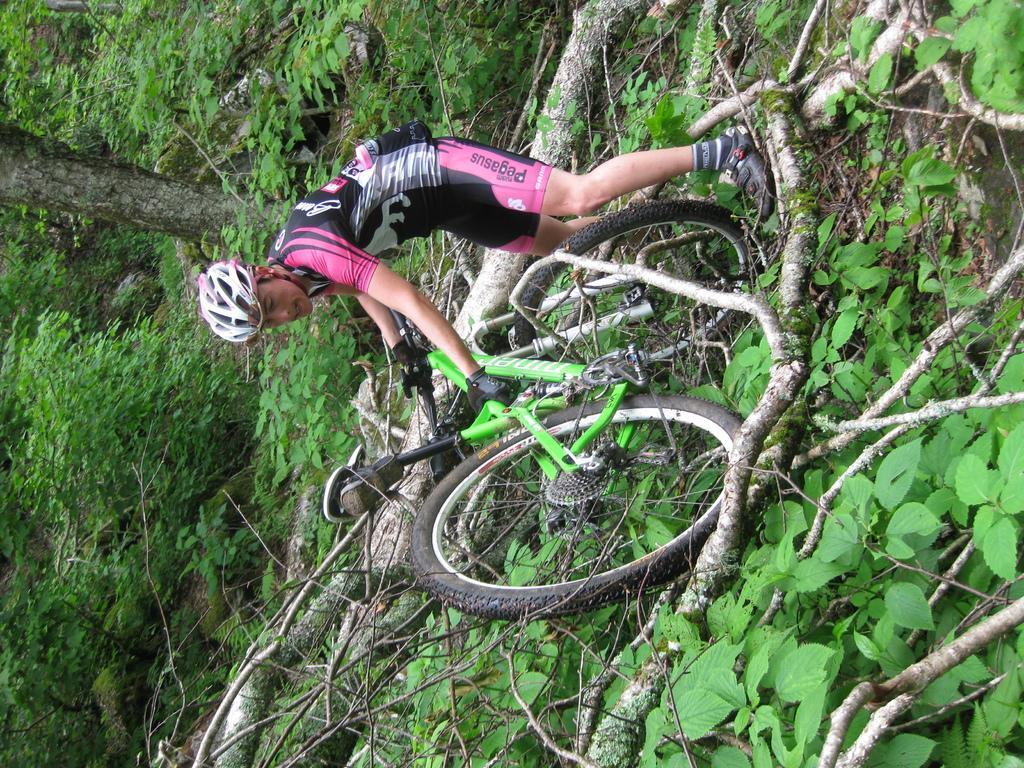Describe this image in one or two sentences. In this image I can see a person standing, wearing a helmet. He is holding a green bicycle. There is a tree fallen on the ground. There are trees at the back. 